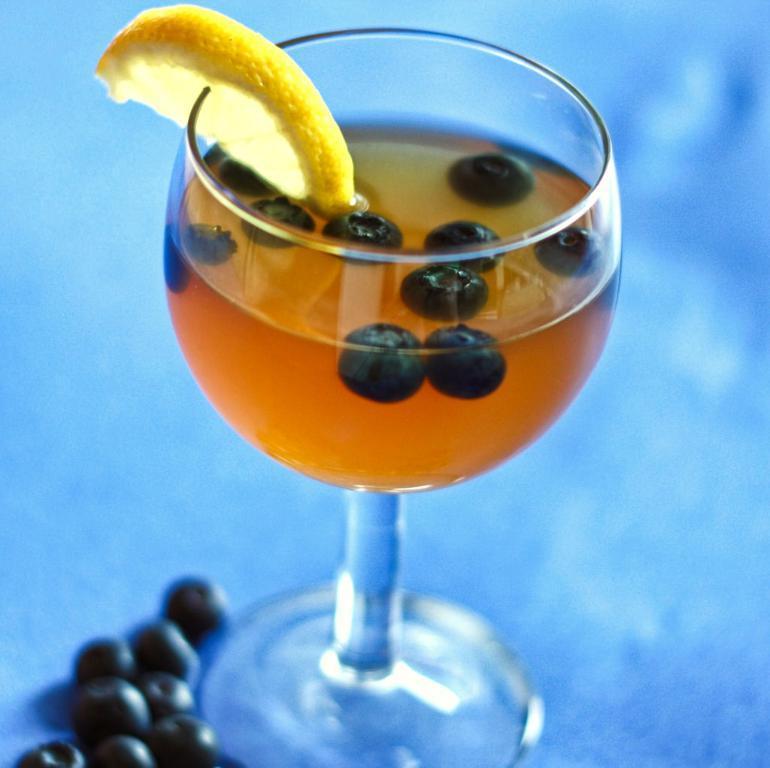Can you describe this image briefly? In the center of this picture we can see the glass of a drink containing berries and we can see the sliced lemon is placed on the edge of the glass and we can see the berries and some other object. 